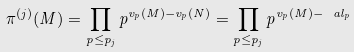<formula> <loc_0><loc_0><loc_500><loc_500>\pi ^ { ( j ) } ( M ) = \prod _ { p \leq p _ { j } } p ^ { v _ { p } ( M ) - v _ { p } ( N ) } = \prod _ { p \leq p _ { j } } p ^ { v _ { p } ( M ) - \ a l _ { p } }</formula> 